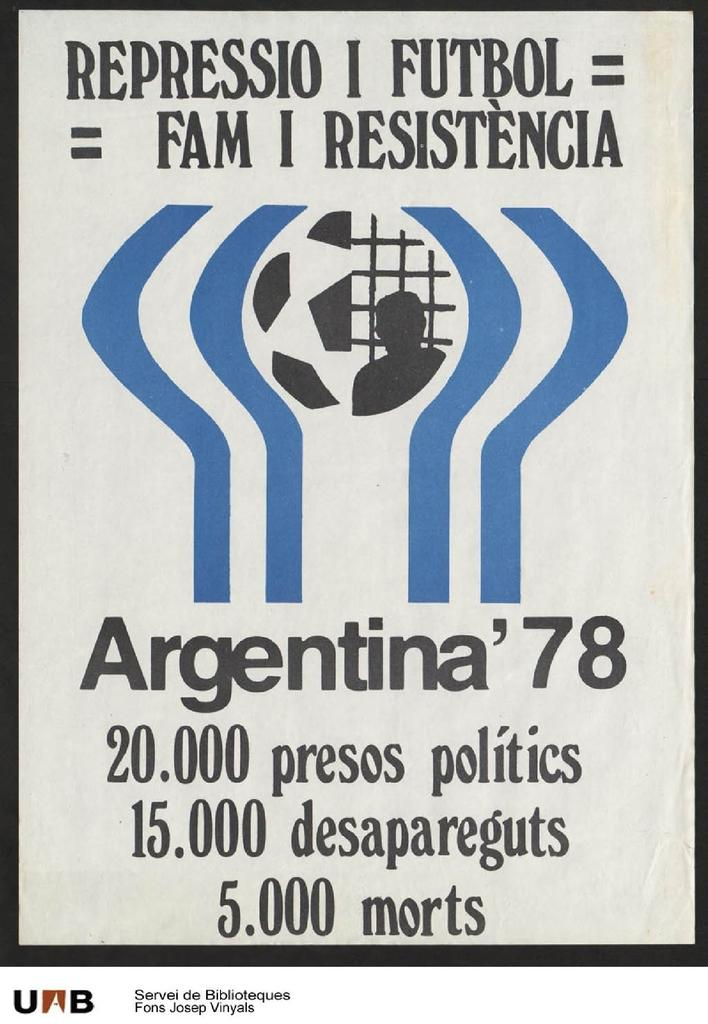<image>
Render a clear and concise summary of the photo. Argentina had a national soccer team in 1978. 